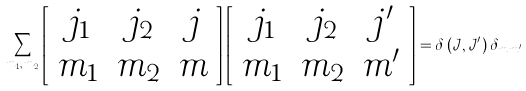<formula> <loc_0><loc_0><loc_500><loc_500>\sum _ { m _ { 1 } , \, m _ { 2 } } \left [ \begin{array} { c c c } j _ { 1 } & j _ { 2 } & j \\ m _ { 1 } & m _ { 2 } & m \end{array} \right ] \left [ \begin{array} { c c c } j _ { 1 } & j _ { 2 } & j ^ { \prime } \\ m _ { 1 } & m _ { 2 } & m ^ { \prime } \end{array} \right ] = \delta \left ( \mathcal { J } , \mathcal { J ^ { \prime } } \right ) \delta _ { m \, m ^ { \prime } }</formula> 